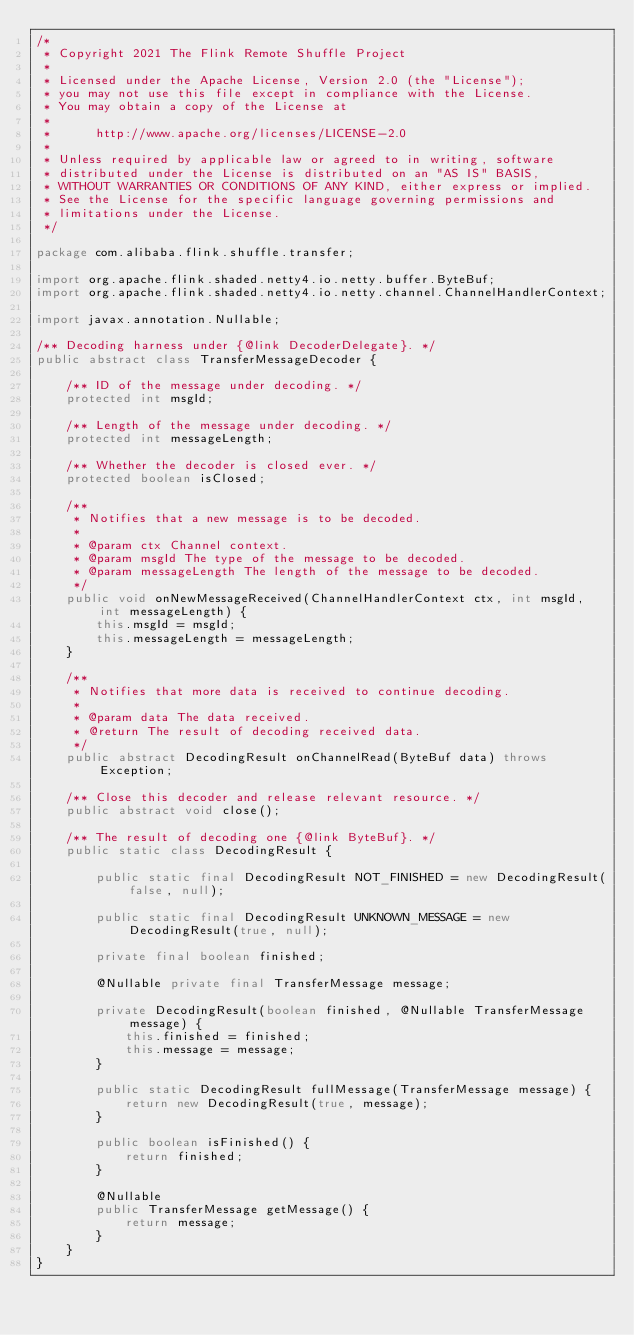Convert code to text. <code><loc_0><loc_0><loc_500><loc_500><_Java_>/*
 * Copyright 2021 The Flink Remote Shuffle Project
 *
 * Licensed under the Apache License, Version 2.0 (the "License");
 * you may not use this file except in compliance with the License.
 * You may obtain a copy of the License at
 *
 *  	http://www.apache.org/licenses/LICENSE-2.0
 *
 * Unless required by applicable law or agreed to in writing, software
 * distributed under the License is distributed on an "AS IS" BASIS,
 * WITHOUT WARRANTIES OR CONDITIONS OF ANY KIND, either express or implied.
 * See the License for the specific language governing permissions and
 * limitations under the License.
 */

package com.alibaba.flink.shuffle.transfer;

import org.apache.flink.shaded.netty4.io.netty.buffer.ByteBuf;
import org.apache.flink.shaded.netty4.io.netty.channel.ChannelHandlerContext;

import javax.annotation.Nullable;

/** Decoding harness under {@link DecoderDelegate}. */
public abstract class TransferMessageDecoder {

    /** ID of the message under decoding. */
    protected int msgId;

    /** Length of the message under decoding. */
    protected int messageLength;

    /** Whether the decoder is closed ever. */
    protected boolean isClosed;

    /**
     * Notifies that a new message is to be decoded.
     *
     * @param ctx Channel context.
     * @param msgId The type of the message to be decoded.
     * @param messageLength The length of the message to be decoded.
     */
    public void onNewMessageReceived(ChannelHandlerContext ctx, int msgId, int messageLength) {
        this.msgId = msgId;
        this.messageLength = messageLength;
    }

    /**
     * Notifies that more data is received to continue decoding.
     *
     * @param data The data received.
     * @return The result of decoding received data.
     */
    public abstract DecodingResult onChannelRead(ByteBuf data) throws Exception;

    /** Close this decoder and release relevant resource. */
    public abstract void close();

    /** The result of decoding one {@link ByteBuf}. */
    public static class DecodingResult {

        public static final DecodingResult NOT_FINISHED = new DecodingResult(false, null);

        public static final DecodingResult UNKNOWN_MESSAGE = new DecodingResult(true, null);

        private final boolean finished;

        @Nullable private final TransferMessage message;

        private DecodingResult(boolean finished, @Nullable TransferMessage message) {
            this.finished = finished;
            this.message = message;
        }

        public static DecodingResult fullMessage(TransferMessage message) {
            return new DecodingResult(true, message);
        }

        public boolean isFinished() {
            return finished;
        }

        @Nullable
        public TransferMessage getMessage() {
            return message;
        }
    }
}
</code> 